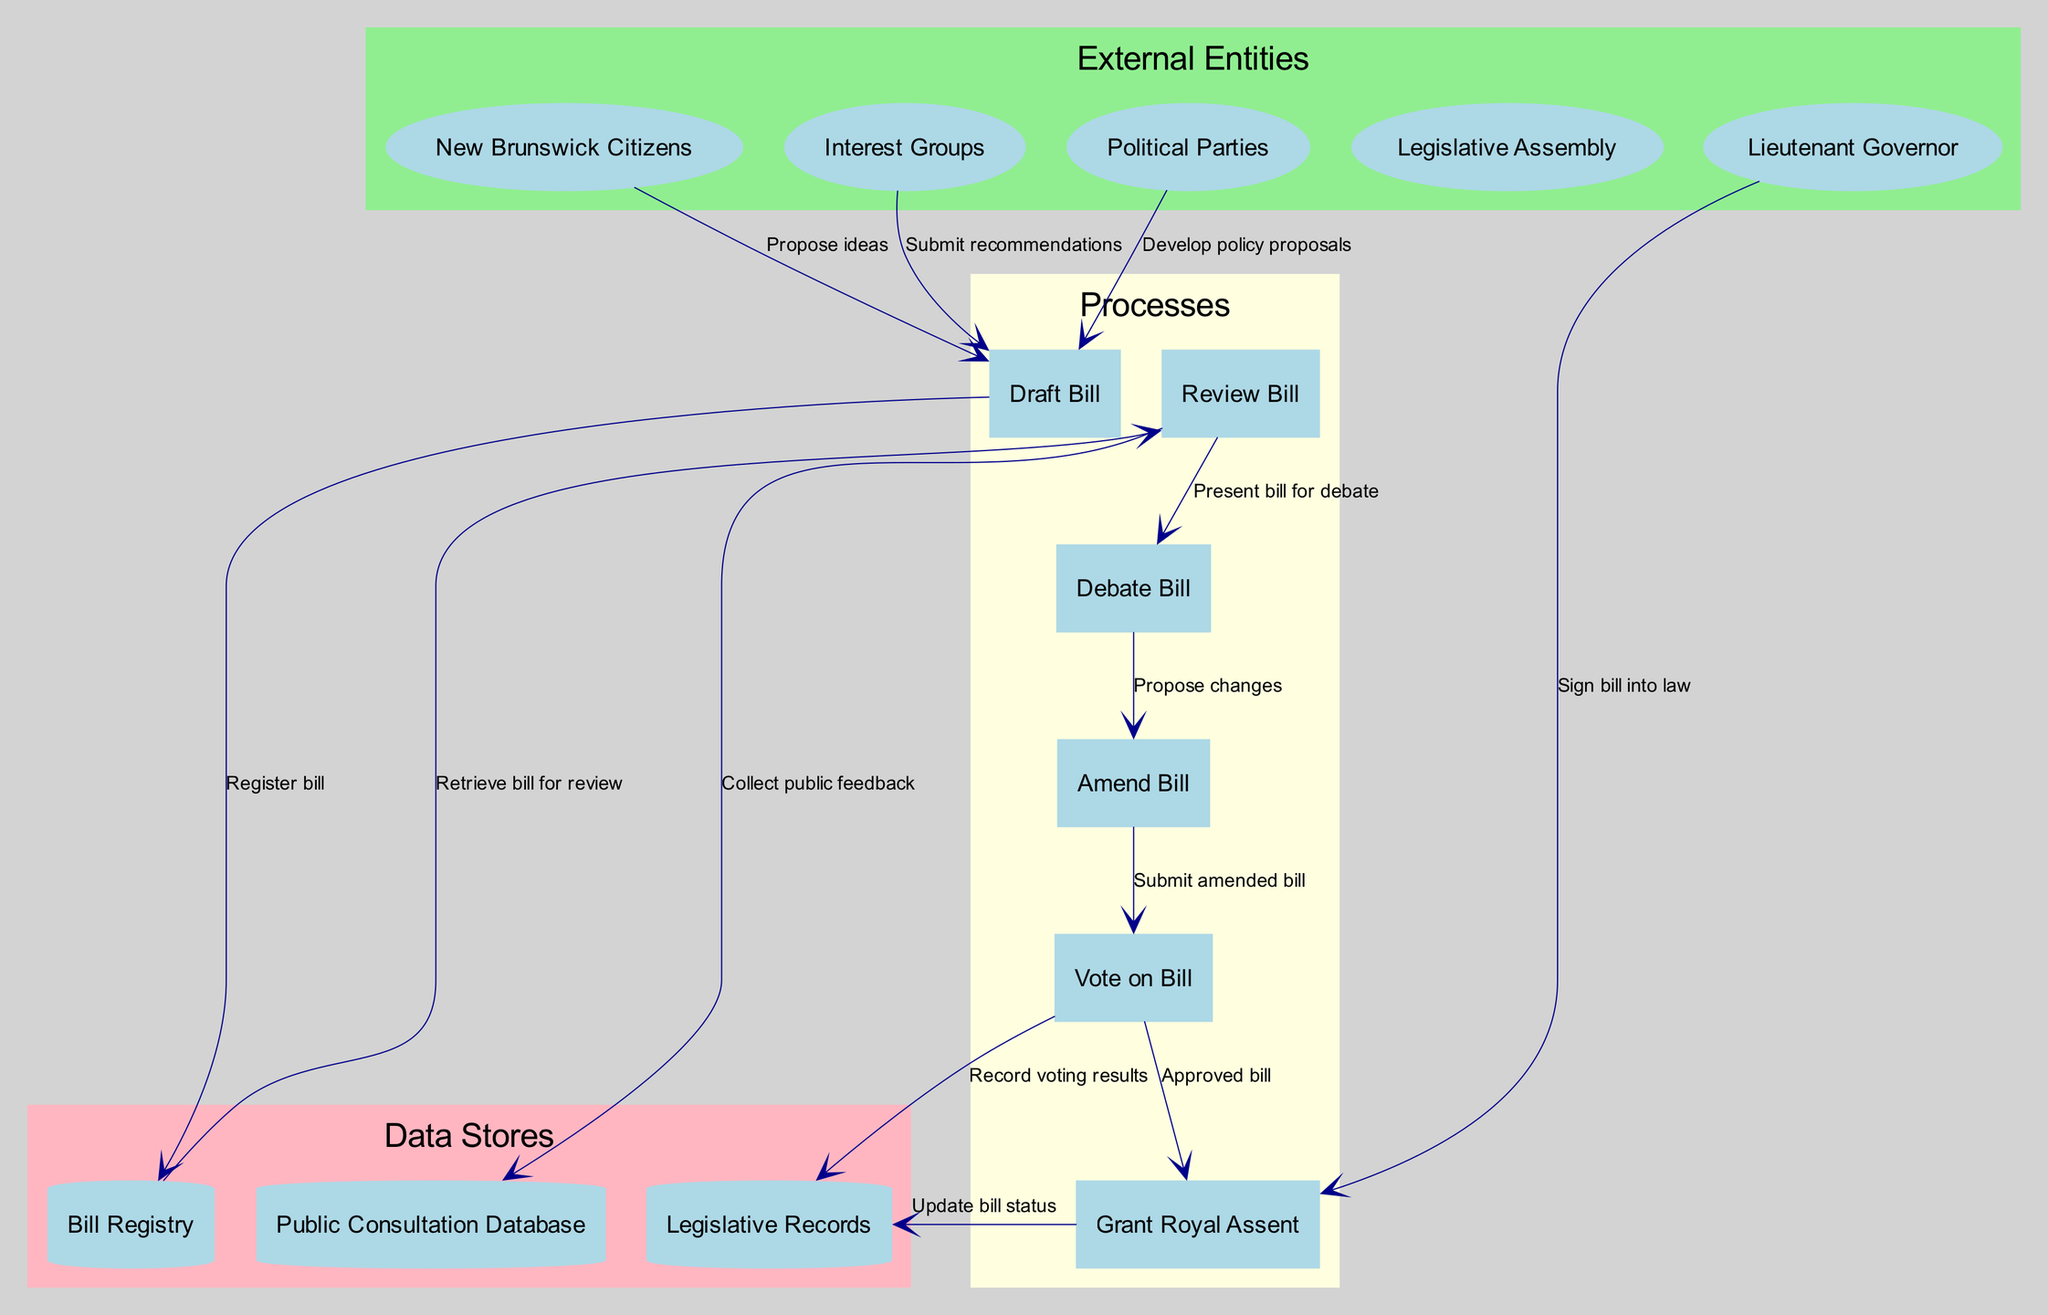What are the external entities involved in the workflow? The diagram lists five external entities: New Brunswick Citizens, Interest Groups, Political Parties, Legislative Assembly, and Lieutenant Governor. These entities interact with the processes throughout the workflow.
Answer: New Brunswick Citizens, Interest Groups, Political Parties, Legislative Assembly, Lieutenant Governor How many processes are there in the diagram? The diagram includes six distinct processes: Draft Bill, Review Bill, Debate Bill, Vote on Bill, Amend Bill, and Grant Royal Assent. By counting each labeled process, it is clear that there are six processes.
Answer: 6 What flow emerges from the "Vote on Bill" process? The "Vote on Bill" process flows to two distinct endpoints: "Legislative Records" which records the voting results, and "Grant Royal Assent" which indicates that the bill has been approved. This outcome reflects the next logical steps in the workflow after a vote.
Answer: Legislative Records, Grant Royal Assent Which data store collects public feedback? The "Public Consultation Database" is the data store specifically designated to collect feedback from the public as part of the review process. This is indicated by the flow from "Review Bill" to "Public Consultation Database."
Answer: Public Consultation Database Who signs the bill into law? The "Lieutenant Governor" is responsible for signing the bill into law, marked by the flow from "Lieutenant Governor" to "Grant Royal Assent." This step is crucial for finalizing the legislative process.
Answer: Lieutenant Governor What does the "Draft Bill" process send to the "Bill Registry"? The "Draft Bill" process sends a labeled output to the "Bill Registry" stating "Register bill," indicating that the drafted bill must be officially recorded within the system for further processing.
Answer: Register bill What happens after the "Debate Bill" process? After the "Debate Bill" process, the next step is the "Amend Bill" process, where proposed changes to the bill are made following the debate. This transition allows for alterations based on discussions during the debate.
Answer: Amend Bill How does public consultation influence the workflow? Public consultation plays a role during the "Review Bill" process, where public feedback is collected and incorporated into the legislative review, guiding representatives in decision-making before debate.
Answer: Collect public feedback 